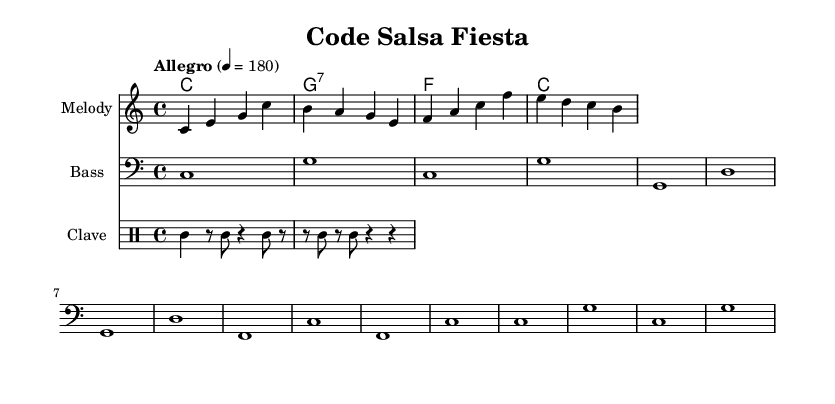What is the key signature of this music? The key signature is C major, which has no sharps or flats.
Answer: C major What is the time signature of this music? The time signature is indicated at the beginning of the score, which shows there are four beats per measure, represented by 4/4.
Answer: 4/4 What is the tempo marking for this piece? The tempo marking is indicated above the staff, showing the piece should be played at a speed of 180 beats per minute, with the instruction "Allegro."
Answer: Allegro How many measures are present in the melody? The melody consists of four measures, which can be counted by looking at the written notes and the bar lines.
Answer: 4 Which chord is played in the second measure of the harmonies? The second measure of the harmonies shows a G7 chord, indicated by the 'g' in the chord notation.
Answer: G7 What rhythmic pattern does the clave rhythm follow? The clave rhythm follows a pattern played as two quarter notes followed by three eighth notes, repeated through the measures shown.
Answer: Clave Which lyric corresponds to the last measure of the melody? The last lyric line contains the word "song," which is sung in conjunction with the last measure of the melody as indicated in the lyrics section.
Answer: song 